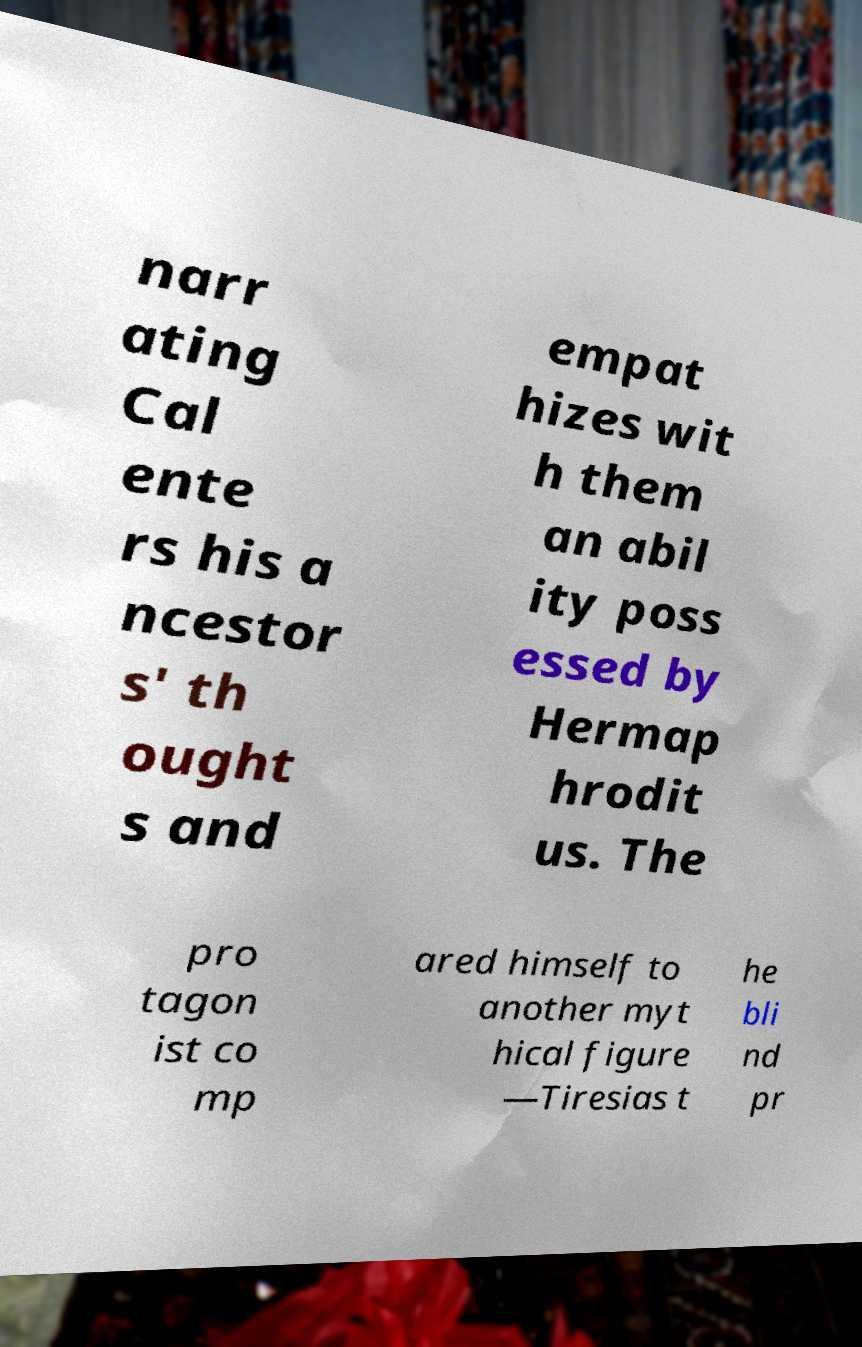Can you read and provide the text displayed in the image?This photo seems to have some interesting text. Can you extract and type it out for me? narr ating Cal ente rs his a ncestor s' th ought s and empat hizes wit h them an abil ity poss essed by Hermap hrodit us. The pro tagon ist co mp ared himself to another myt hical figure —Tiresias t he bli nd pr 